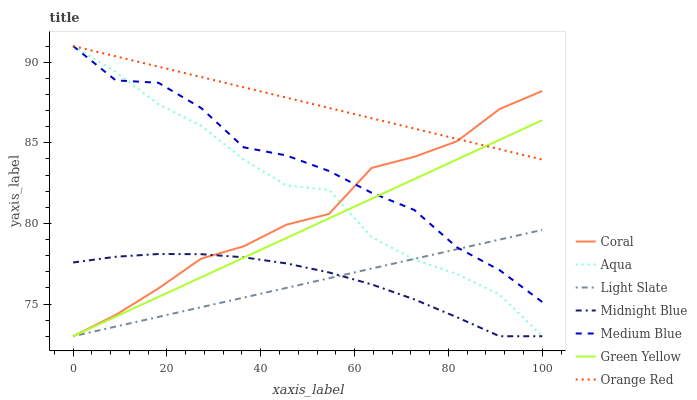Does Light Slate have the minimum area under the curve?
Answer yes or no. Yes. Does Orange Red have the maximum area under the curve?
Answer yes or no. Yes. Does Aqua have the minimum area under the curve?
Answer yes or no. No. Does Aqua have the maximum area under the curve?
Answer yes or no. No. Is Green Yellow the smoothest?
Answer yes or no. Yes. Is Medium Blue the roughest?
Answer yes or no. Yes. Is Light Slate the smoothest?
Answer yes or no. No. Is Light Slate the roughest?
Answer yes or no. No. Does Midnight Blue have the lowest value?
Answer yes or no. Yes. Does Medium Blue have the lowest value?
Answer yes or no. No. Does Orange Red have the highest value?
Answer yes or no. Yes. Does Light Slate have the highest value?
Answer yes or no. No. Is Light Slate less than Orange Red?
Answer yes or no. Yes. Is Orange Red greater than Light Slate?
Answer yes or no. Yes. Does Coral intersect Aqua?
Answer yes or no. Yes. Is Coral less than Aqua?
Answer yes or no. No. Is Coral greater than Aqua?
Answer yes or no. No. Does Light Slate intersect Orange Red?
Answer yes or no. No. 